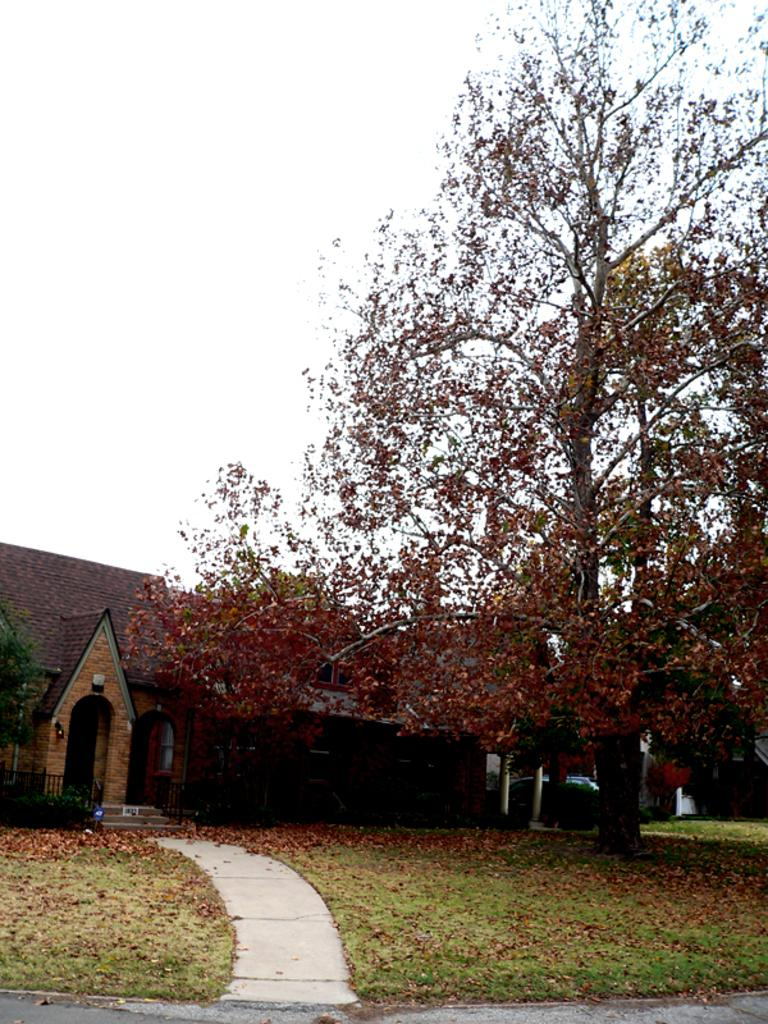What type of surface can be seen in the image? There is a path in the image. What type of vegetation is present in the image? There is grass and leaves on the ground in the image. What type of natural structures are visible in the image? There are trees in the image. What type of man-made structure is visible in the image? There is a building in the image. What type of vehicle is visible in the image? There is a car in the image. What is visible in the background of the image? The sky is visible in the background of the image. What type of guitar can be seen hanging on the tree in the image? There is no guitar present in the image; it only features a path, grass, leaves, trees, a building, a car, and the sky. What is the price of the car in the image? The price of the car cannot be determined from the image alone, as it does not provide any information about the make, model, or condition of the vehicle. 